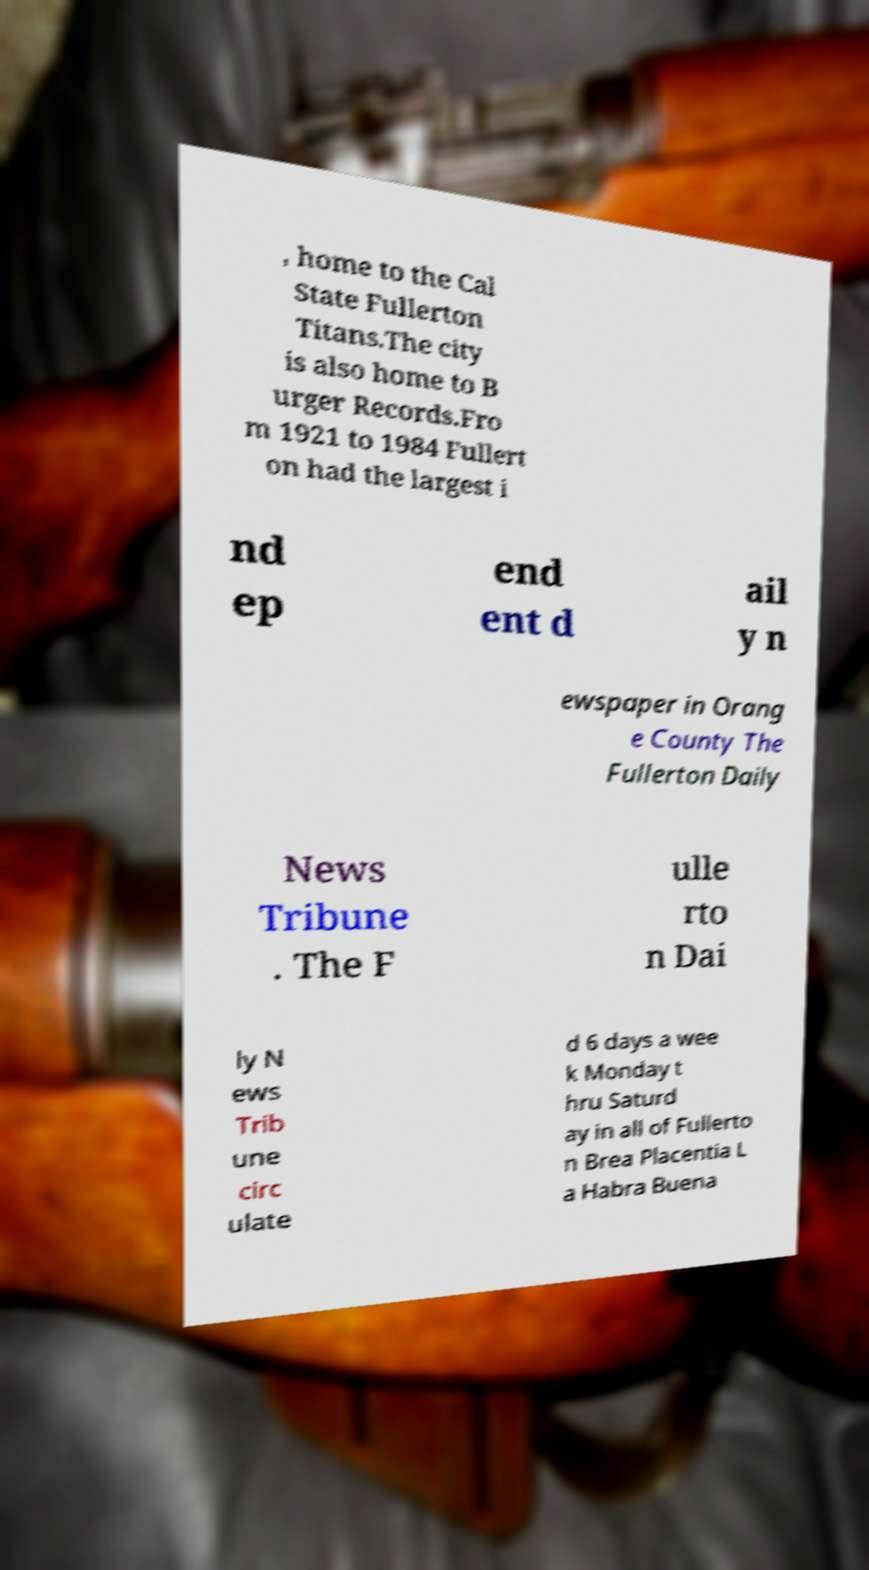What messages or text are displayed in this image? I need them in a readable, typed format. , home to the Cal State Fullerton Titans.The city is also home to B urger Records.Fro m 1921 to 1984 Fullert on had the largest i nd ep end ent d ail y n ewspaper in Orang e County The Fullerton Daily News Tribune . The F ulle rto n Dai ly N ews Trib une circ ulate d 6 days a wee k Monday t hru Saturd ay in all of Fullerto n Brea Placentia L a Habra Buena 